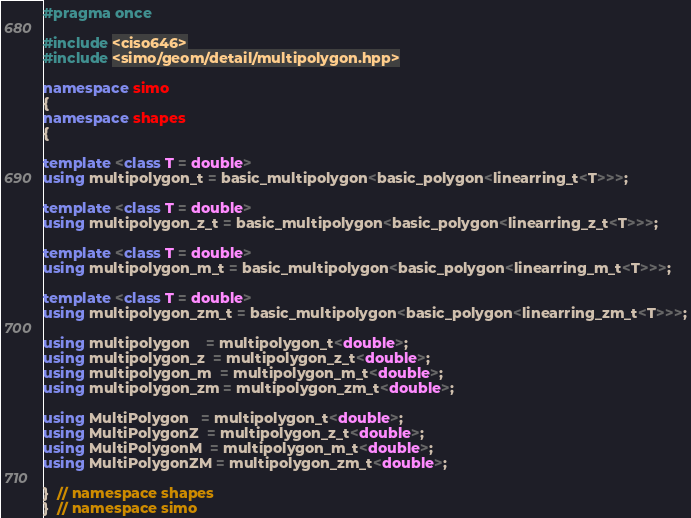Convert code to text. <code><loc_0><loc_0><loc_500><loc_500><_C++_>#pragma once

#include <ciso646>
#include <simo/geom/detail/multipolygon.hpp>

namespace simo
{
namespace shapes
{

template <class T = double>
using multipolygon_t = basic_multipolygon<basic_polygon<linearring_t<T>>>;

template <class T = double>
using multipolygon_z_t = basic_multipolygon<basic_polygon<linearring_z_t<T>>>;

template <class T = double>
using multipolygon_m_t = basic_multipolygon<basic_polygon<linearring_m_t<T>>>;

template <class T = double>
using multipolygon_zm_t = basic_multipolygon<basic_polygon<linearring_zm_t<T>>>;

using multipolygon    = multipolygon_t<double>;
using multipolygon_z  = multipolygon_z_t<double>;
using multipolygon_m  = multipolygon_m_t<double>;
using multipolygon_zm = multipolygon_zm_t<double>;

using MultiPolygon   = multipolygon_t<double>;
using MultiPolygonZ  = multipolygon_z_t<double>;
using MultiPolygonM  = multipolygon_m_t<double>;
using MultiPolygonZM = multipolygon_zm_t<double>;

}  // namespace shapes
}  // namespace simo</code> 